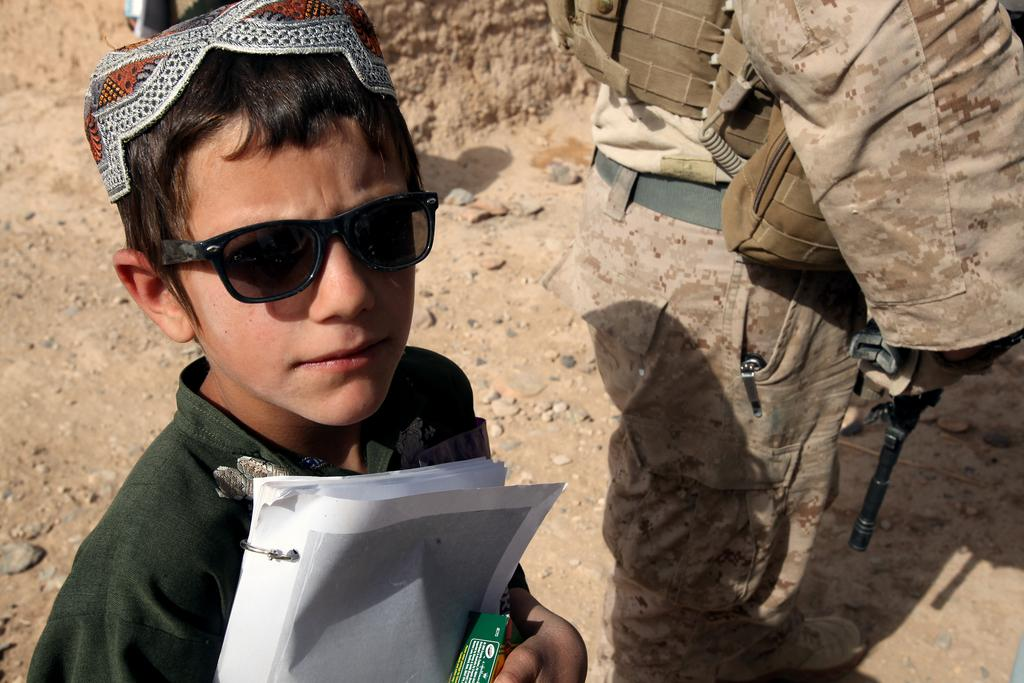What are the people in the image doing? The persons in the image are standing on the ground. Can you describe what one of the persons is holding? One of the persons is holding papers in their hands. How many dogs are present in the image? There are no dogs present in the image. What type of wound can be seen on the person holding the papers? There is no wound visible on the person holding the papers in the image. 